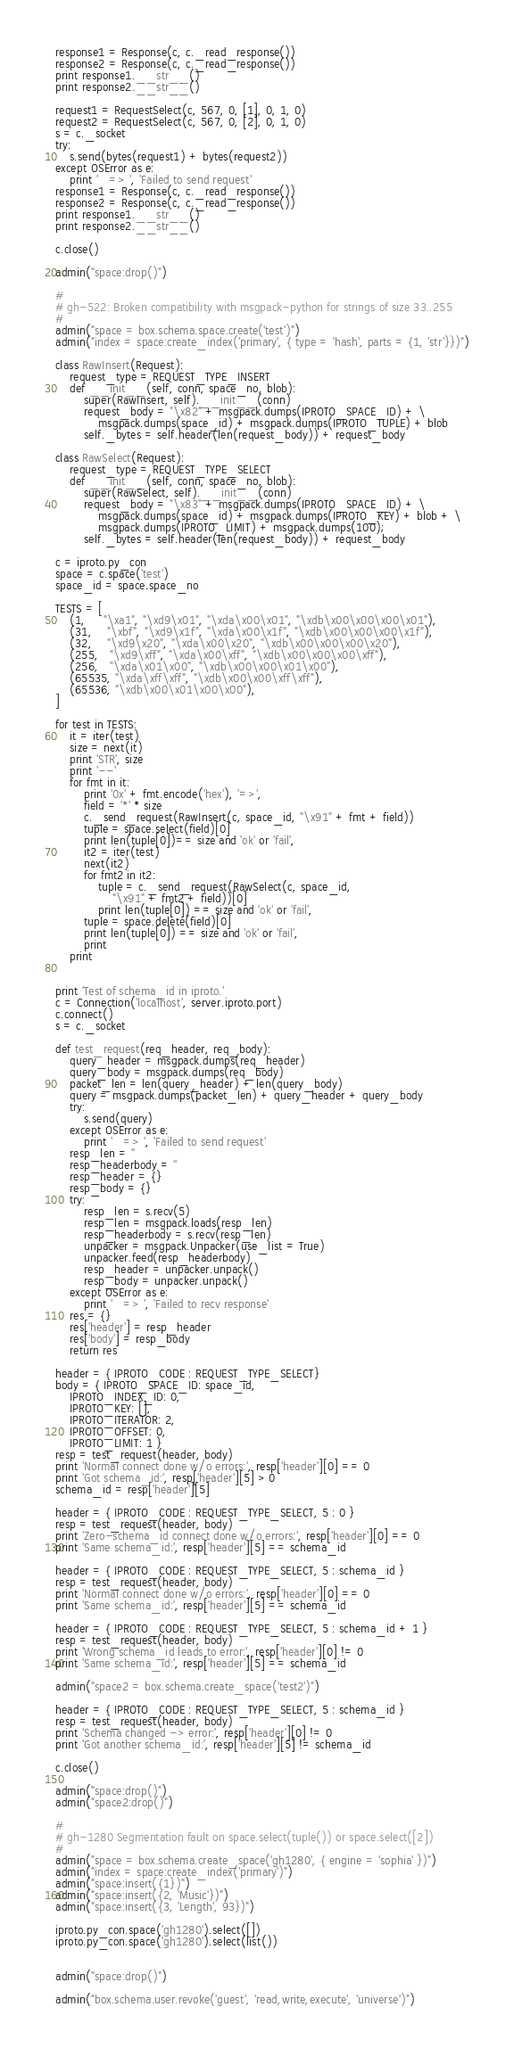Convert code to text. <code><loc_0><loc_0><loc_500><loc_500><_Python_>response1 = Response(c, c._read_response())
response2 = Response(c, c._read_response())
print response1.__str__()
print response2.__str__()

request1 = RequestSelect(c, 567, 0, [1], 0, 1, 0)
request2 = RequestSelect(c, 567, 0, [2], 0, 1, 0)
s = c._socket
try:
    s.send(bytes(request1) + bytes(request2))
except OSError as e:
    print '   => ', 'Failed to send request'
response1 = Response(c, c._read_response())
response2 = Response(c, c._read_response())
print response1.__str__()
print response2.__str__()

c.close()

admin("space:drop()")

#
# gh-522: Broken compatibility with msgpack-python for strings of size 33..255
#
admin("space = box.schema.space.create('test')")
admin("index = space:create_index('primary', { type = 'hash', parts = {1, 'str'}})")

class RawInsert(Request):
    request_type = REQUEST_TYPE_INSERT
    def __init__(self, conn, space_no, blob):
        super(RawInsert, self).__init__(conn)
        request_body = "\x82" + msgpack.dumps(IPROTO_SPACE_ID) + \
            msgpack.dumps(space_id) + msgpack.dumps(IPROTO_TUPLE) + blob
        self._bytes = self.header(len(request_body)) + request_body

class RawSelect(Request):
    request_type = REQUEST_TYPE_SELECT
    def __init__(self, conn, space_no, blob):
        super(RawSelect, self).__init__(conn)
        request_body = "\x83" + msgpack.dumps(IPROTO_SPACE_ID) + \
            msgpack.dumps(space_id) + msgpack.dumps(IPROTO_KEY) + blob + \
            msgpack.dumps(IPROTO_LIMIT) + msgpack.dumps(100);
        self._bytes = self.header(len(request_body)) + request_body

c = iproto.py_con
space = c.space('test')
space_id = space.space_no

TESTS = [
    (1,     "\xa1", "\xd9\x01", "\xda\x00\x01", "\xdb\x00\x00\x00\x01"),
    (31,    "\xbf", "\xd9\x1f", "\xda\x00\x1f", "\xdb\x00\x00\x00\x1f"),
    (32,    "\xd9\x20", "\xda\x00\x20", "\xdb\x00\x00\x00\x20"),
    (255,   "\xd9\xff", "\xda\x00\xff", "\xdb\x00\x00\x00\xff"),
    (256,   "\xda\x01\x00", "\xdb\x00\x00\x01\x00"),
    (65535, "\xda\xff\xff", "\xdb\x00\x00\xff\xff"),
    (65536, "\xdb\x00\x01\x00\x00"),
]

for test in TESTS:
    it = iter(test)
    size = next(it)
    print 'STR', size
    print '--'
    for fmt in it:
        print '0x' + fmt.encode('hex'), '=>',
        field = '*' * size
        c._send_request(RawInsert(c, space_id, "\x91" + fmt + field))
        tuple = space.select(field)[0]
        print len(tuple[0])== size and 'ok' or 'fail',
        it2 = iter(test)
        next(it2)
        for fmt2 in it2:
            tuple = c._send_request(RawSelect(c, space_id,
                "\x91" + fmt2 + field))[0]
            print len(tuple[0]) == size and 'ok' or 'fail',
        tuple = space.delete(field)[0]
        print len(tuple[0]) == size and 'ok' or 'fail',
        print
    print


print 'Test of schema_id in iproto.'
c = Connection('localhost', server.iproto.port)
c.connect()
s = c._socket

def test_request(req_header, req_body):
    query_header = msgpack.dumps(req_header)
    query_body = msgpack.dumps(req_body)
    packet_len = len(query_header) + len(query_body)
    query = msgpack.dumps(packet_len) + query_header + query_body
    try:
        s.send(query)
    except OSError as e:
        print '   => ', 'Failed to send request'
    resp_len = ''
    resp_headerbody = ''
    resp_header = {}
    resp_body = {}
    try:
        resp_len = s.recv(5)
        resp_len = msgpack.loads(resp_len)
        resp_headerbody = s.recv(resp_len)
        unpacker = msgpack.Unpacker(use_list = True)
        unpacker.feed(resp_headerbody)
        resp_header = unpacker.unpack()
        resp_body = unpacker.unpack()
    except OSError as e:
        print '   => ', 'Failed to recv response'
    res = {}
    res['header'] = resp_header
    res['body'] = resp_body
    return res

header = { IPROTO_CODE : REQUEST_TYPE_SELECT}
body = { IPROTO_SPACE_ID: space_id,
    IPROTO_INDEX_ID: 0,
    IPROTO_KEY: [],
    IPROTO_ITERATOR: 2,
    IPROTO_OFFSET: 0,
    IPROTO_LIMIT: 1 }
resp = test_request(header, body)
print 'Normal connect done w/o errors:', resp['header'][0] == 0
print 'Got schema_id:', resp['header'][5] > 0
schema_id = resp['header'][5]

header = { IPROTO_CODE : REQUEST_TYPE_SELECT, 5 : 0 }
resp = test_request(header, body)
print 'Zero-schema_id connect done w/o errors:', resp['header'][0] == 0
print 'Same schema_id:', resp['header'][5] == schema_id

header = { IPROTO_CODE : REQUEST_TYPE_SELECT, 5 : schema_id }
resp = test_request(header, body)
print 'Normal connect done w/o errors:', resp['header'][0] == 0
print 'Same schema_id:', resp['header'][5] == schema_id

header = { IPROTO_CODE : REQUEST_TYPE_SELECT, 5 : schema_id + 1 }
resp = test_request(header, body)
print 'Wrong schema_id leads to error:', resp['header'][0] != 0
print 'Same schema_id:', resp['header'][5] == schema_id

admin("space2 = box.schema.create_space('test2')")

header = { IPROTO_CODE : REQUEST_TYPE_SELECT, 5 : schema_id }
resp = test_request(header, body)
print 'Schema changed -> error:', resp['header'][0] != 0
print 'Got another schema_id:', resp['header'][5] != schema_id

c.close()

admin("space:drop()")
admin("space2:drop()")

#
# gh-1280 Segmentation fault on space.select(tuple()) or space.select([2])
#
admin("space = box.schema.create_space('gh1280', { engine = 'sophia' })")
admin("index = space:create_index('primary')")
admin("space:insert({1})")
admin("space:insert({2, 'Music'})")
admin("space:insert({3, 'Length', 93})")

iproto.py_con.space('gh1280').select([])
iproto.py_con.space('gh1280').select(list())


admin("space:drop()")

admin("box.schema.user.revoke('guest', 'read,write,execute', 'universe')")
</code> 